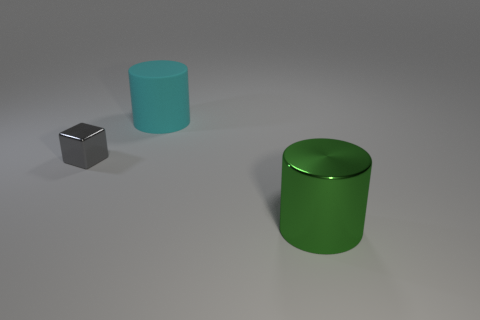Add 2 small metal blocks. How many objects exist? 5 Subtract all gray cylinders. Subtract all brown blocks. How many cylinders are left? 2 Subtract all cylinders. How many objects are left? 1 Add 3 metal things. How many metal things are left? 5 Add 3 small blue rubber balls. How many small blue rubber balls exist? 3 Subtract 0 cyan spheres. How many objects are left? 3 Subtract all rubber cubes. Subtract all gray shiny blocks. How many objects are left? 2 